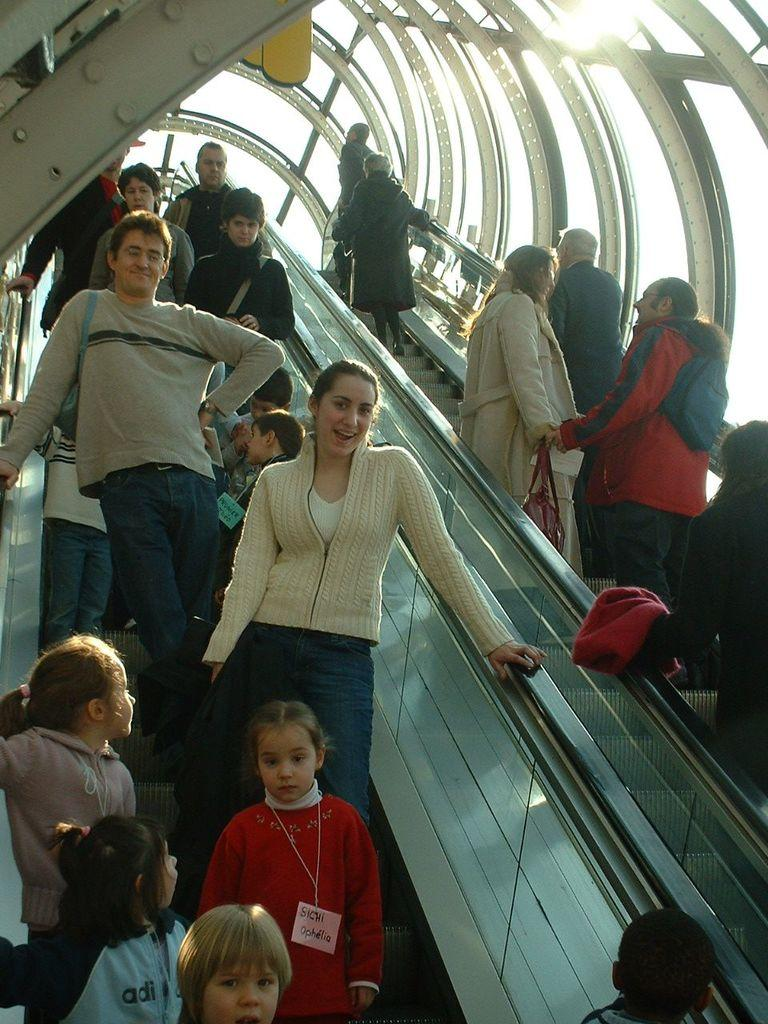What is happening in the image involving a group of people? The people are standing on escalators in the image. What can be seen above the escalators? There is a roof visible at the top of the escalators. What is visible in the background of the image? The sky is visible in the image. What is the weather like in the image? There is sunshine in the image, indicating a clear day. What type of comb is being used by the people in the image? There is no comb visible in the image; the people are standing on escalators. What is the plot of the story being told in the image? The image does not depict a story or plot; it shows people on escalators. 